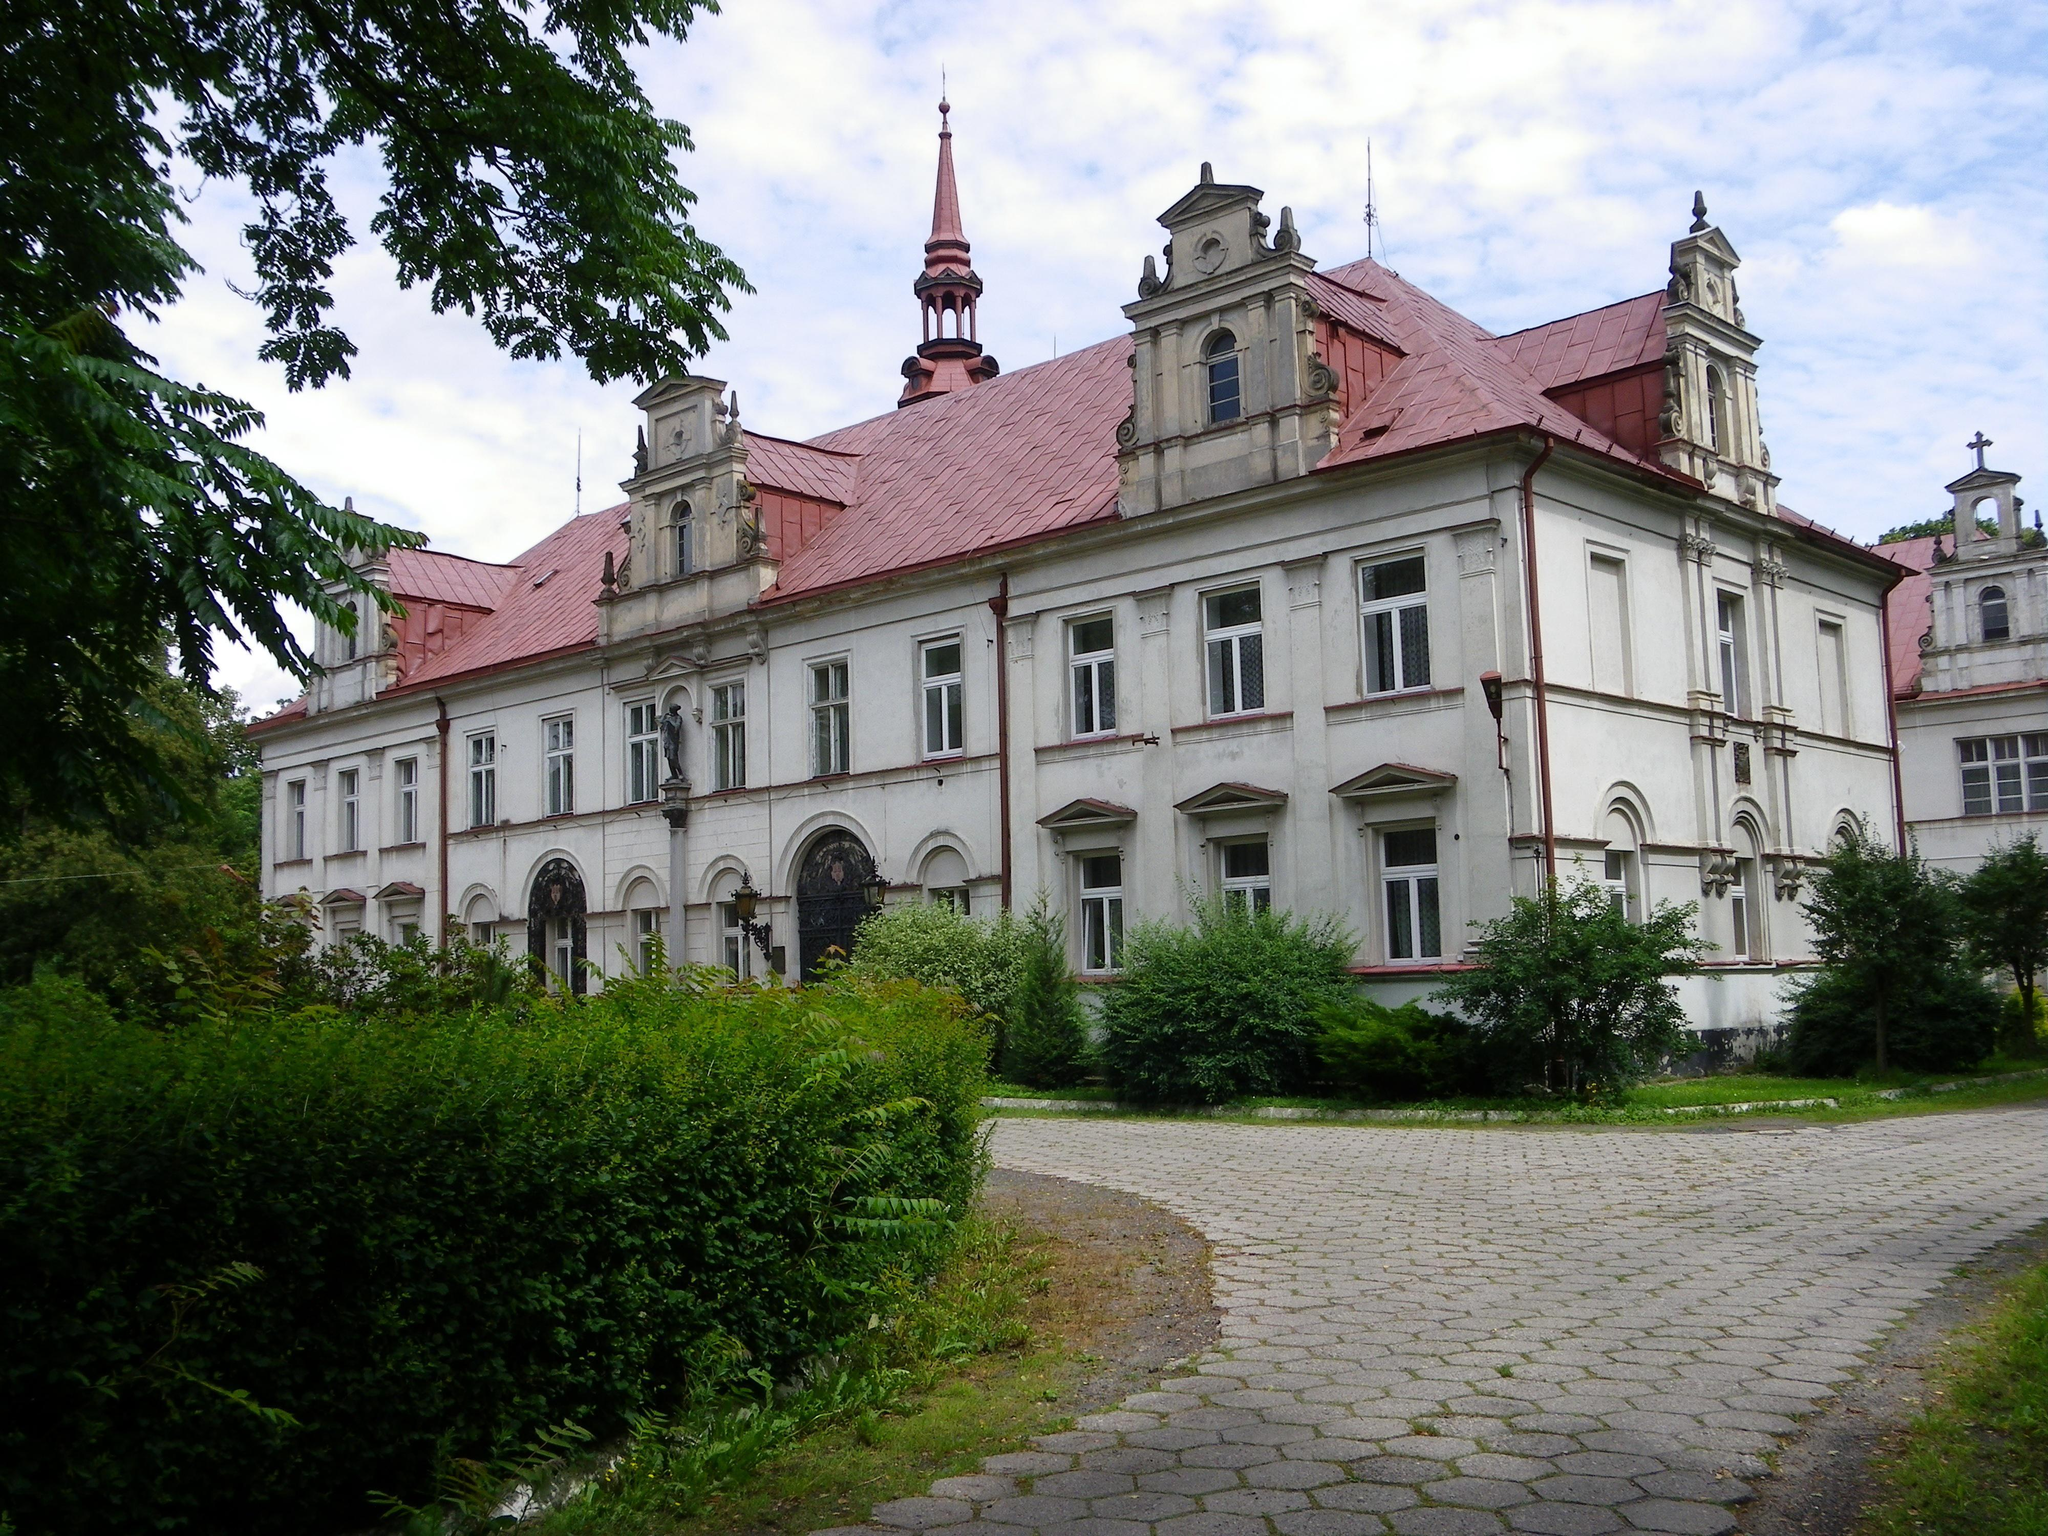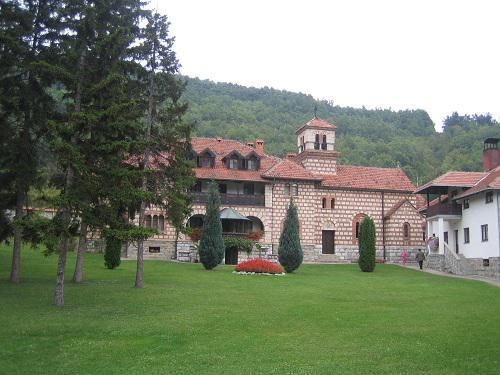The first image is the image on the left, the second image is the image on the right. Assess this claim about the two images: "The house on the left has at least one arch shape around a window or door.". Correct or not? Answer yes or no. Yes. 